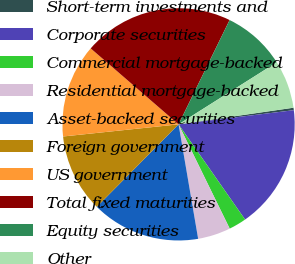Convert chart. <chart><loc_0><loc_0><loc_500><loc_500><pie_chart><fcel>Short-term investments and<fcel>Corporate securities<fcel>Commercial mortgage-backed<fcel>Residential mortgage-backed<fcel>Asset-backed securities<fcel>Foreign government<fcel>US government<fcel>Total fixed maturities<fcel>Equity securities<fcel>Other<nl><fcel>0.34%<fcel>17.24%<fcel>2.45%<fcel>4.56%<fcel>15.13%<fcel>10.9%<fcel>13.01%<fcel>20.9%<fcel>8.79%<fcel>6.68%<nl></chart> 